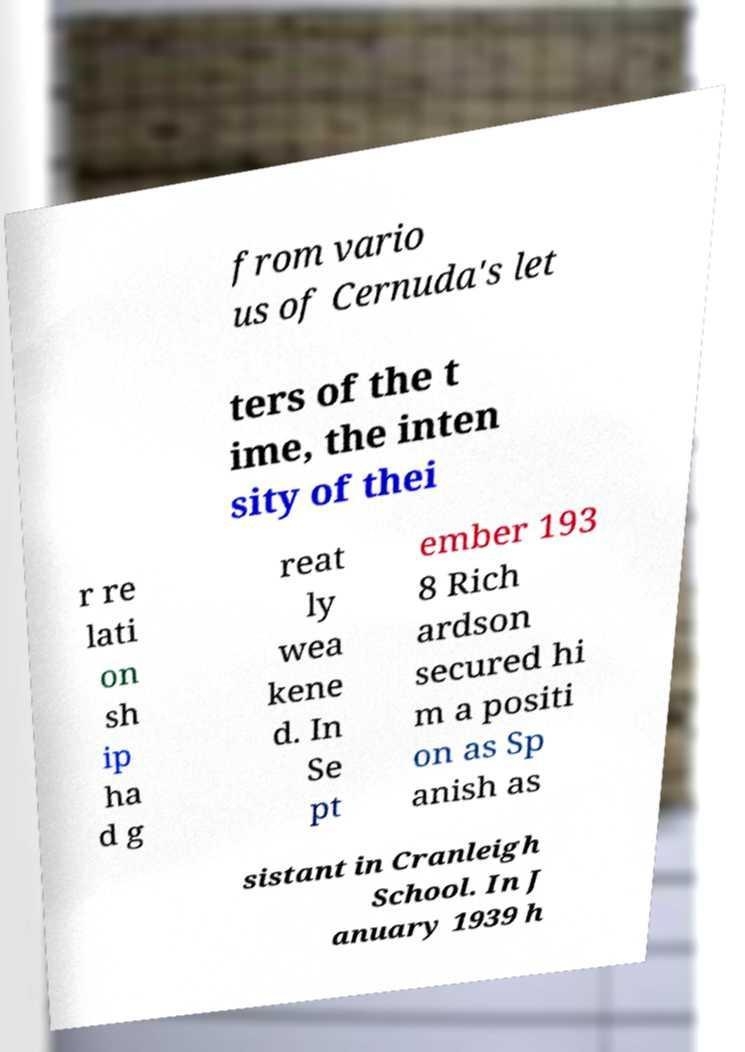I need the written content from this picture converted into text. Can you do that? from vario us of Cernuda's let ters of the t ime, the inten sity of thei r re lati on sh ip ha d g reat ly wea kene d. In Se pt ember 193 8 Rich ardson secured hi m a positi on as Sp anish as sistant in Cranleigh School. In J anuary 1939 h 